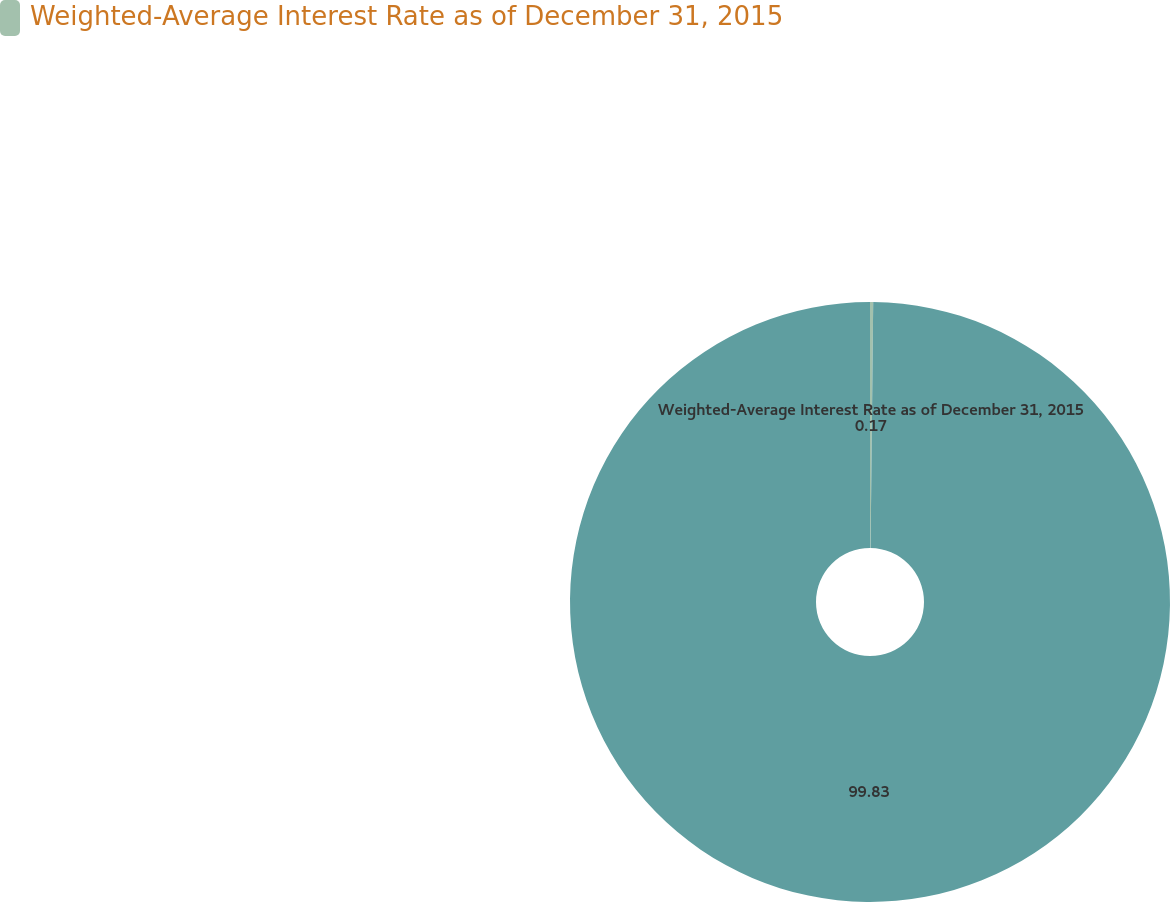Convert chart to OTSL. <chart><loc_0><loc_0><loc_500><loc_500><pie_chart><fcel>Weighted-Average Interest Rate as of December 31, 2015<fcel>Unnamed: 1<nl><fcel>0.17%<fcel>99.83%<nl></chart> 